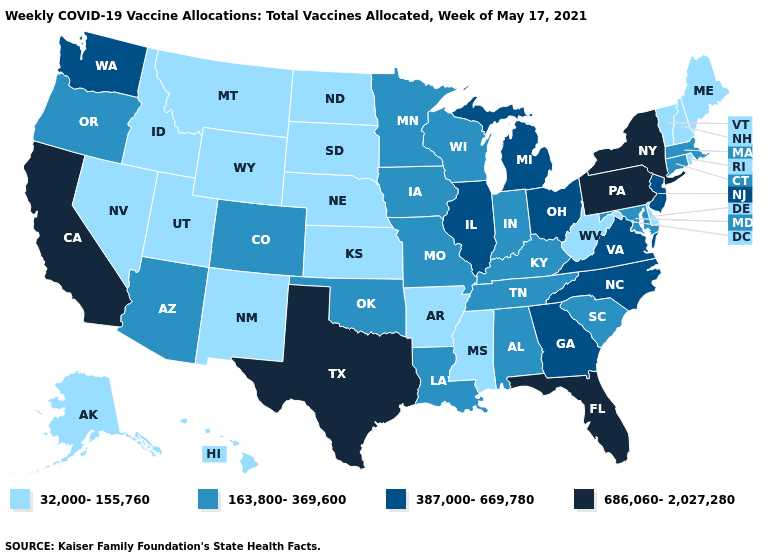What is the lowest value in the South?
Quick response, please. 32,000-155,760. Name the states that have a value in the range 163,800-369,600?
Short answer required. Alabama, Arizona, Colorado, Connecticut, Indiana, Iowa, Kentucky, Louisiana, Maryland, Massachusetts, Minnesota, Missouri, Oklahoma, Oregon, South Carolina, Tennessee, Wisconsin. Name the states that have a value in the range 686,060-2,027,280?
Concise answer only. California, Florida, New York, Pennsylvania, Texas. Name the states that have a value in the range 387,000-669,780?
Answer briefly. Georgia, Illinois, Michigan, New Jersey, North Carolina, Ohio, Virginia, Washington. Is the legend a continuous bar?
Write a very short answer. No. What is the value of Montana?
Quick response, please. 32,000-155,760. Among the states that border Oklahoma , does Kansas have the lowest value?
Concise answer only. Yes. Does Texas have the highest value in the USA?
Keep it brief. Yes. What is the value of Mississippi?
Write a very short answer. 32,000-155,760. Name the states that have a value in the range 387,000-669,780?
Write a very short answer. Georgia, Illinois, Michigan, New Jersey, North Carolina, Ohio, Virginia, Washington. Name the states that have a value in the range 387,000-669,780?
Short answer required. Georgia, Illinois, Michigan, New Jersey, North Carolina, Ohio, Virginia, Washington. What is the highest value in states that border Illinois?
Be succinct. 163,800-369,600. Does Wisconsin have the lowest value in the USA?
Answer briefly. No. What is the value of Georgia?
Write a very short answer. 387,000-669,780. Does Montana have a lower value than North Carolina?
Concise answer only. Yes. 